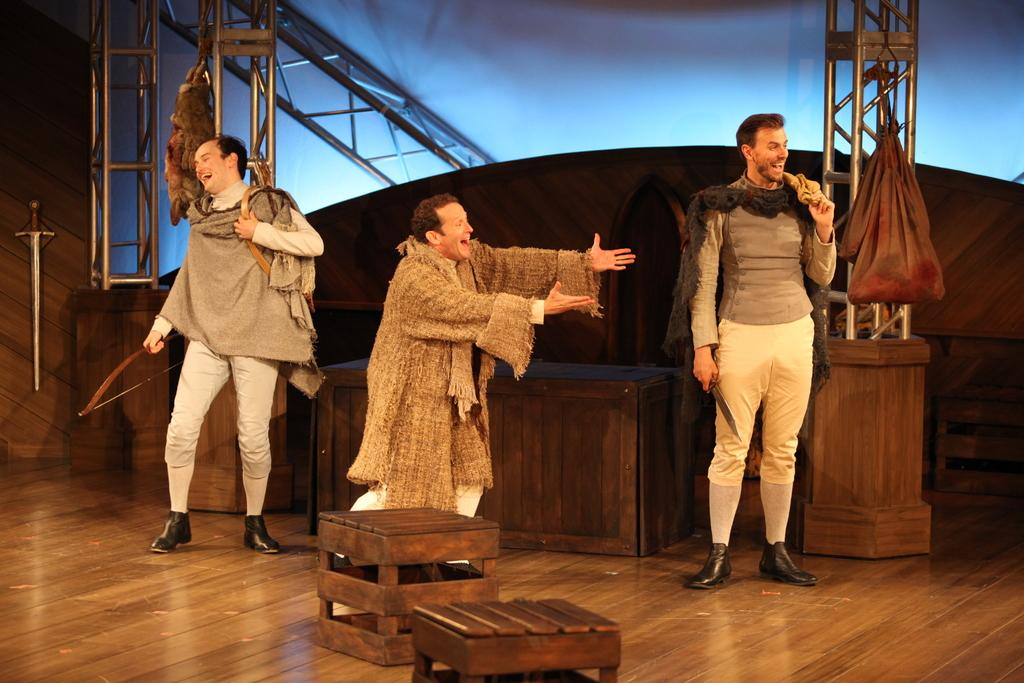What are the people in the image doing? The persons standing in the center of the image are smiling. Can you describe the background of the image? There is a wall, tables, and pole-type structures in the background of the image. What type of shoe is visible on the person's foot in the image? There is no shoe visible on any person's foot in the image. What type of camera is being used to take the picture in the image? There is no camera visible in the image, as it is a still photograph. 